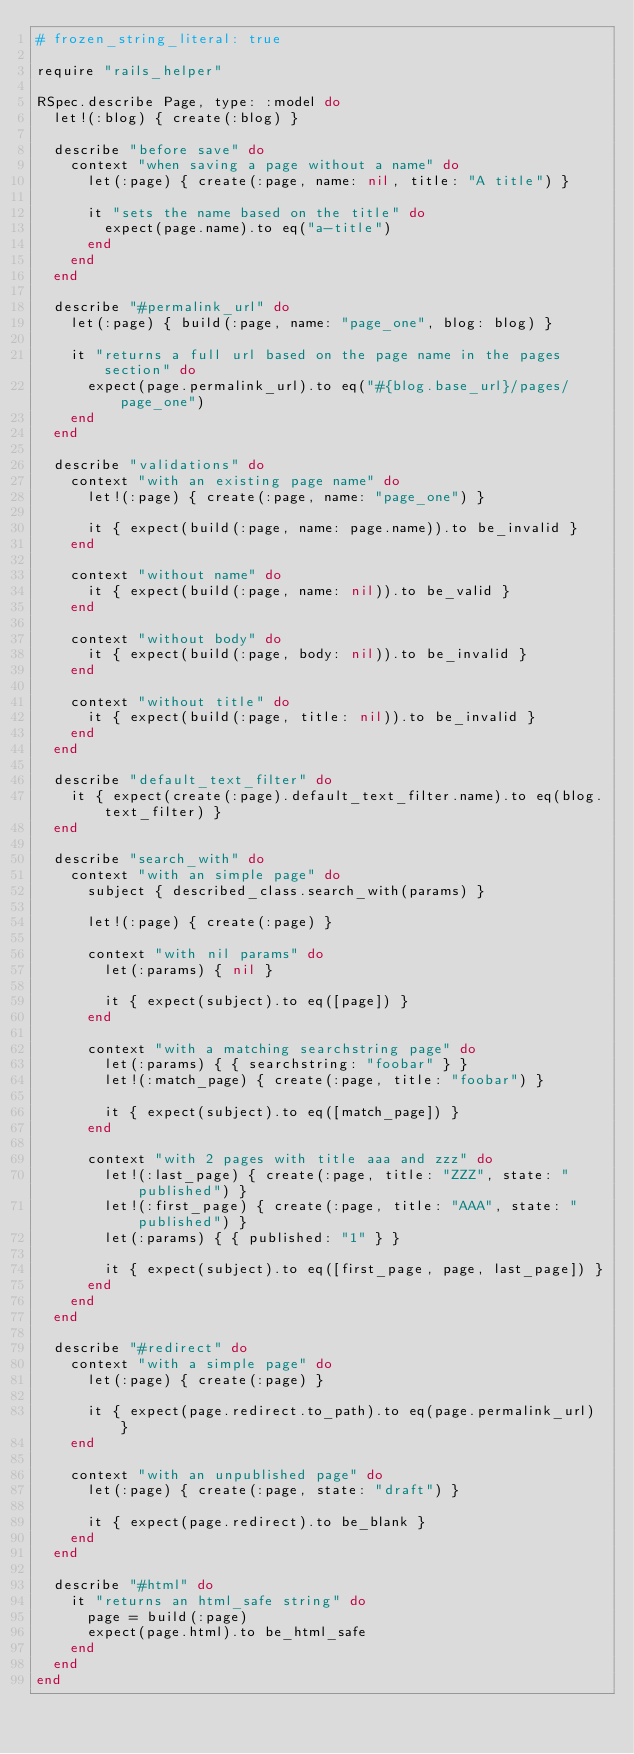Convert code to text. <code><loc_0><loc_0><loc_500><loc_500><_Ruby_># frozen_string_literal: true

require "rails_helper"

RSpec.describe Page, type: :model do
  let!(:blog) { create(:blog) }

  describe "before save" do
    context "when saving a page without a name" do
      let(:page) { create(:page, name: nil, title: "A title") }

      it "sets the name based on the title" do
        expect(page.name).to eq("a-title")
      end
    end
  end

  describe "#permalink_url" do
    let(:page) { build(:page, name: "page_one", blog: blog) }

    it "returns a full url based on the page name in the pages section" do
      expect(page.permalink_url).to eq("#{blog.base_url}/pages/page_one")
    end
  end

  describe "validations" do
    context "with an existing page name" do
      let!(:page) { create(:page, name: "page_one") }

      it { expect(build(:page, name: page.name)).to be_invalid }
    end

    context "without name" do
      it { expect(build(:page, name: nil)).to be_valid }
    end

    context "without body" do
      it { expect(build(:page, body: nil)).to be_invalid }
    end

    context "without title" do
      it { expect(build(:page, title: nil)).to be_invalid }
    end
  end

  describe "default_text_filter" do
    it { expect(create(:page).default_text_filter.name).to eq(blog.text_filter) }
  end

  describe "search_with" do
    context "with an simple page" do
      subject { described_class.search_with(params) }

      let!(:page) { create(:page) }

      context "with nil params" do
        let(:params) { nil }

        it { expect(subject).to eq([page]) }
      end

      context "with a matching searchstring page" do
        let(:params) { { searchstring: "foobar" } }
        let!(:match_page) { create(:page, title: "foobar") }

        it { expect(subject).to eq([match_page]) }
      end

      context "with 2 pages with title aaa and zzz" do
        let!(:last_page) { create(:page, title: "ZZZ", state: "published") }
        let!(:first_page) { create(:page, title: "AAA", state: "published") }
        let(:params) { { published: "1" } }

        it { expect(subject).to eq([first_page, page, last_page]) }
      end
    end
  end

  describe "#redirect" do
    context "with a simple page" do
      let(:page) { create(:page) }

      it { expect(page.redirect.to_path).to eq(page.permalink_url) }
    end

    context "with an unpublished page" do
      let(:page) { create(:page, state: "draft") }

      it { expect(page.redirect).to be_blank }
    end
  end

  describe "#html" do
    it "returns an html_safe string" do
      page = build(:page)
      expect(page.html).to be_html_safe
    end
  end
end
</code> 